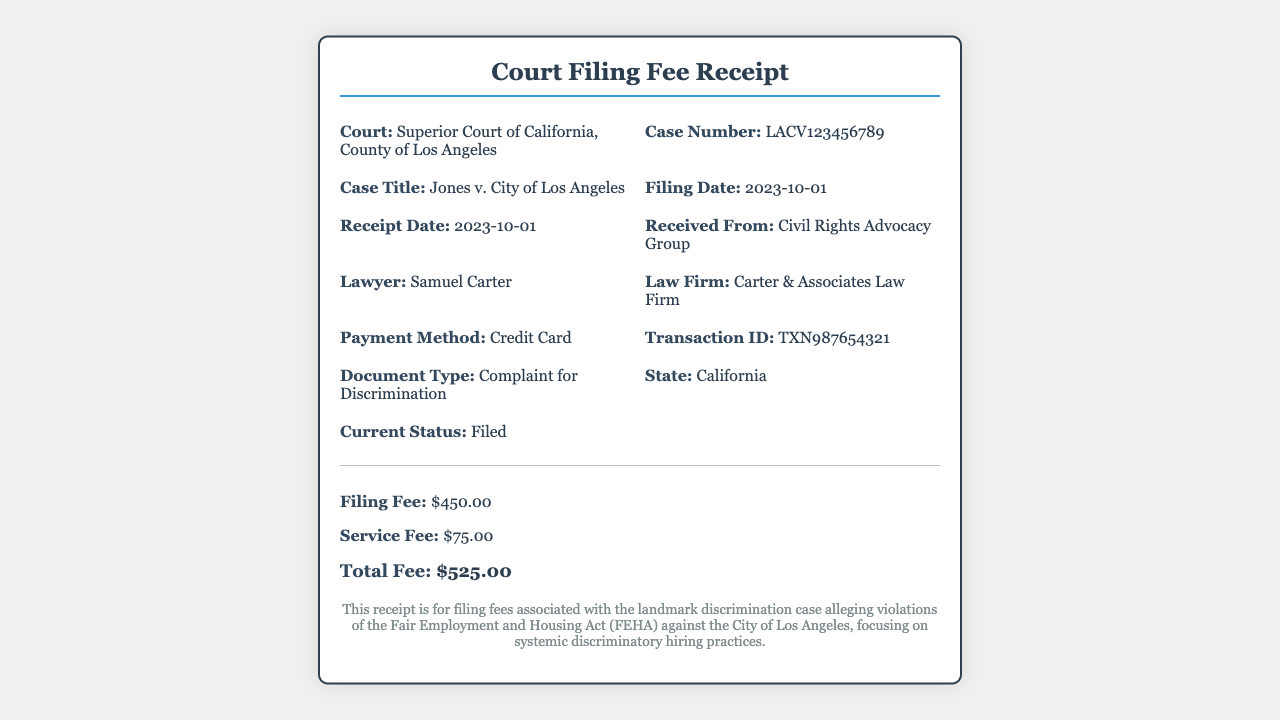what is the court name? The court name is explicitly stated in the receipt, identifying the specific court involved in the case.
Answer: Superior Court of California, County of Los Angeles what is the case number? The case number is a unique identifier for the legal case listed on the receipt.
Answer: LACV123456789 who is the plaintiff in the case title? The plaintiff is the first name listed in the case title on the receipt, indicating who is bringing the complaint.
Answer: Jones what is the filing fee amount? The filing fee amount is explicitly stated in the fees section of the receipt.
Answer: $450.00 what was the payment method? The payment method indicates how the filing fee was paid, as mentioned in the receipt details.
Answer: Credit Card what is the receipt date? The receipt date is the same as the filing date as mentioned in the document, reflecting when the payment was processed.
Answer: 2023-10-01 what is the total fee charged? The total fee charged is calculated from the fees section on the receipt, combining both the filing and service fees.
Answer: $525.00 who received the payment? The recipient of the payment is mentioned clearly in the receipt, specifying the organization involved.
Answer: Civil Rights Advocacy Group what is the document type filed? The document type indicates the nature of the legal filing made in the case, which is defined in the receipt.
Answer: Complaint for Discrimination 